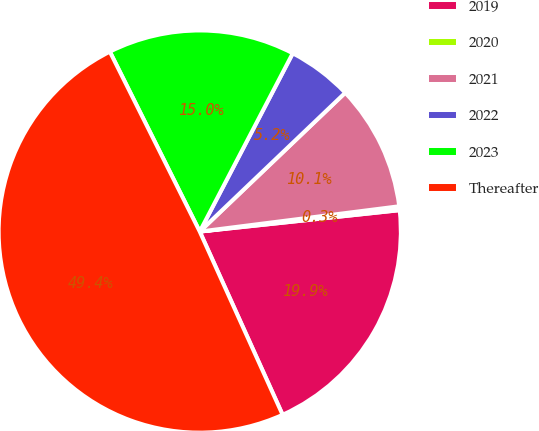Convert chart. <chart><loc_0><loc_0><loc_500><loc_500><pie_chart><fcel>2019<fcel>2020<fcel>2021<fcel>2022<fcel>2023<fcel>Thereafter<nl><fcel>19.94%<fcel>0.31%<fcel>10.12%<fcel>5.22%<fcel>15.03%<fcel>49.39%<nl></chart> 